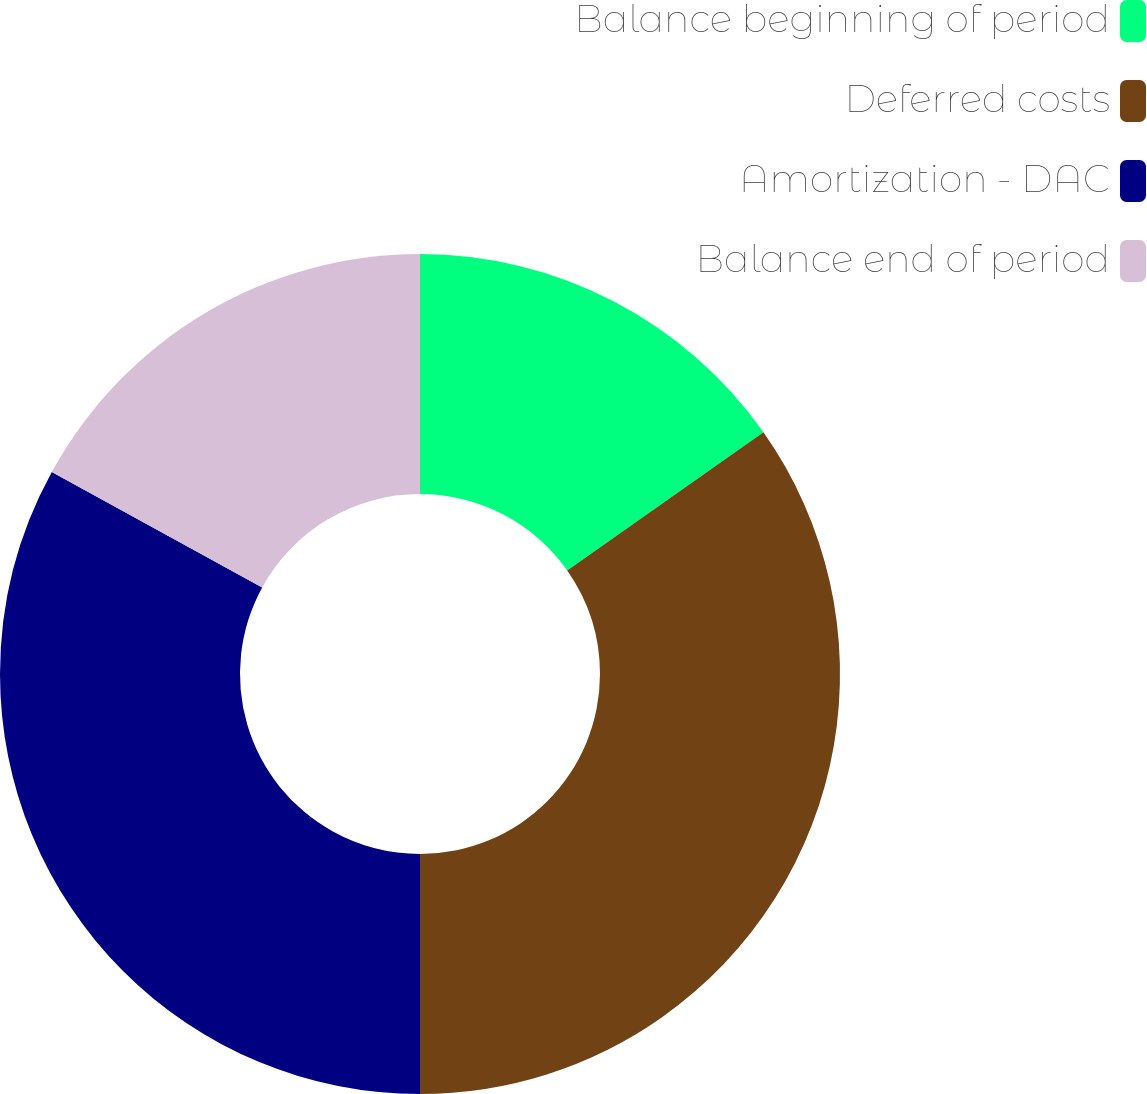<chart> <loc_0><loc_0><loc_500><loc_500><pie_chart><fcel>Balance beginning of period<fcel>Deferred costs<fcel>Amortization - DAC<fcel>Balance end of period<nl><fcel>15.24%<fcel>34.76%<fcel>32.99%<fcel>17.01%<nl></chart> 